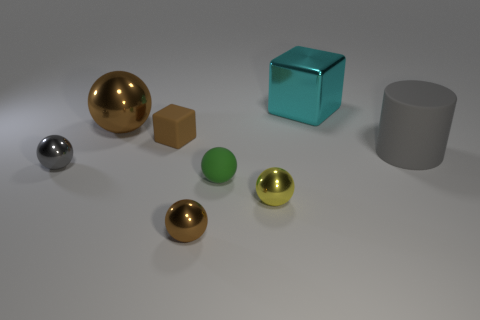Subtract all brown balls. How many were subtracted if there are1brown balls left? 1 Subtract all large brown shiny spheres. How many spheres are left? 4 Subtract all cubes. How many objects are left? 6 Add 2 tiny gray spheres. How many objects exist? 10 Subtract all gray spheres. How many spheres are left? 4 Subtract 4 spheres. How many spheres are left? 1 Subtract all blue spheres. Subtract all green cylinders. How many spheres are left? 5 Subtract all purple cylinders. How many cyan blocks are left? 1 Subtract all cyan metal cubes. Subtract all cyan metallic blocks. How many objects are left? 6 Add 2 matte cubes. How many matte cubes are left? 3 